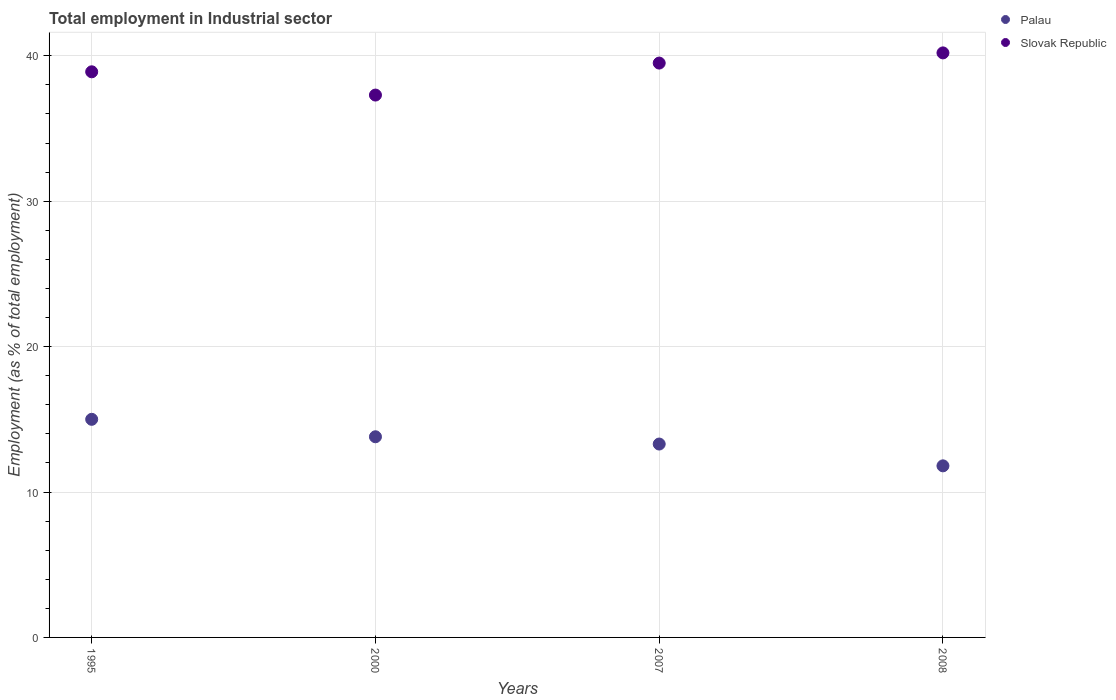How many different coloured dotlines are there?
Make the answer very short. 2. What is the employment in industrial sector in Slovak Republic in 2000?
Ensure brevity in your answer.  37.3. Across all years, what is the maximum employment in industrial sector in Palau?
Offer a terse response. 15. Across all years, what is the minimum employment in industrial sector in Palau?
Provide a short and direct response. 11.8. In which year was the employment in industrial sector in Palau maximum?
Offer a very short reply. 1995. What is the total employment in industrial sector in Slovak Republic in the graph?
Offer a terse response. 155.9. What is the difference between the employment in industrial sector in Slovak Republic in 1995 and that in 2000?
Your answer should be compact. 1.6. What is the difference between the employment in industrial sector in Palau in 2000 and the employment in industrial sector in Slovak Republic in 2008?
Your answer should be compact. -26.4. What is the average employment in industrial sector in Palau per year?
Make the answer very short. 13.48. In the year 2008, what is the difference between the employment in industrial sector in Palau and employment in industrial sector in Slovak Republic?
Keep it short and to the point. -28.4. What is the ratio of the employment in industrial sector in Slovak Republic in 2007 to that in 2008?
Provide a succinct answer. 0.98. Is the employment in industrial sector in Slovak Republic in 1995 less than that in 2008?
Your response must be concise. Yes. Is the difference between the employment in industrial sector in Palau in 2000 and 2008 greater than the difference between the employment in industrial sector in Slovak Republic in 2000 and 2008?
Provide a succinct answer. Yes. What is the difference between the highest and the second highest employment in industrial sector in Slovak Republic?
Provide a short and direct response. 0.7. What is the difference between the highest and the lowest employment in industrial sector in Slovak Republic?
Your answer should be compact. 2.9. In how many years, is the employment in industrial sector in Slovak Republic greater than the average employment in industrial sector in Slovak Republic taken over all years?
Offer a terse response. 2. How many dotlines are there?
Offer a terse response. 2. What is the difference between two consecutive major ticks on the Y-axis?
Offer a terse response. 10. Does the graph contain any zero values?
Your response must be concise. No. Does the graph contain grids?
Offer a very short reply. Yes. Where does the legend appear in the graph?
Keep it short and to the point. Top right. What is the title of the graph?
Make the answer very short. Total employment in Industrial sector. Does "Middle East & North Africa (developing only)" appear as one of the legend labels in the graph?
Your response must be concise. No. What is the label or title of the X-axis?
Give a very brief answer. Years. What is the label or title of the Y-axis?
Provide a short and direct response. Employment (as % of total employment). What is the Employment (as % of total employment) of Slovak Republic in 1995?
Your answer should be compact. 38.9. What is the Employment (as % of total employment) of Palau in 2000?
Ensure brevity in your answer.  13.8. What is the Employment (as % of total employment) of Slovak Republic in 2000?
Offer a terse response. 37.3. What is the Employment (as % of total employment) of Palau in 2007?
Provide a short and direct response. 13.3. What is the Employment (as % of total employment) in Slovak Republic in 2007?
Give a very brief answer. 39.5. What is the Employment (as % of total employment) of Palau in 2008?
Your response must be concise. 11.8. What is the Employment (as % of total employment) of Slovak Republic in 2008?
Offer a terse response. 40.2. Across all years, what is the maximum Employment (as % of total employment) of Slovak Republic?
Offer a very short reply. 40.2. Across all years, what is the minimum Employment (as % of total employment) in Palau?
Provide a short and direct response. 11.8. Across all years, what is the minimum Employment (as % of total employment) in Slovak Republic?
Your response must be concise. 37.3. What is the total Employment (as % of total employment) of Palau in the graph?
Your answer should be compact. 53.9. What is the total Employment (as % of total employment) of Slovak Republic in the graph?
Your answer should be compact. 155.9. What is the difference between the Employment (as % of total employment) in Slovak Republic in 1995 and that in 2007?
Keep it short and to the point. -0.6. What is the difference between the Employment (as % of total employment) of Slovak Republic in 1995 and that in 2008?
Keep it short and to the point. -1.3. What is the difference between the Employment (as % of total employment) in Palau in 2000 and that in 2007?
Provide a short and direct response. 0.5. What is the difference between the Employment (as % of total employment) of Slovak Republic in 2000 and that in 2007?
Provide a short and direct response. -2.2. What is the difference between the Employment (as % of total employment) of Palau in 2000 and that in 2008?
Give a very brief answer. 2. What is the difference between the Employment (as % of total employment) of Palau in 2007 and that in 2008?
Offer a very short reply. 1.5. What is the difference between the Employment (as % of total employment) in Palau in 1995 and the Employment (as % of total employment) in Slovak Republic in 2000?
Make the answer very short. -22.3. What is the difference between the Employment (as % of total employment) of Palau in 1995 and the Employment (as % of total employment) of Slovak Republic in 2007?
Keep it short and to the point. -24.5. What is the difference between the Employment (as % of total employment) of Palau in 1995 and the Employment (as % of total employment) of Slovak Republic in 2008?
Make the answer very short. -25.2. What is the difference between the Employment (as % of total employment) in Palau in 2000 and the Employment (as % of total employment) in Slovak Republic in 2007?
Your answer should be compact. -25.7. What is the difference between the Employment (as % of total employment) in Palau in 2000 and the Employment (as % of total employment) in Slovak Republic in 2008?
Give a very brief answer. -26.4. What is the difference between the Employment (as % of total employment) in Palau in 2007 and the Employment (as % of total employment) in Slovak Republic in 2008?
Keep it short and to the point. -26.9. What is the average Employment (as % of total employment) in Palau per year?
Give a very brief answer. 13.47. What is the average Employment (as % of total employment) of Slovak Republic per year?
Your answer should be very brief. 38.98. In the year 1995, what is the difference between the Employment (as % of total employment) of Palau and Employment (as % of total employment) of Slovak Republic?
Make the answer very short. -23.9. In the year 2000, what is the difference between the Employment (as % of total employment) in Palau and Employment (as % of total employment) in Slovak Republic?
Give a very brief answer. -23.5. In the year 2007, what is the difference between the Employment (as % of total employment) in Palau and Employment (as % of total employment) in Slovak Republic?
Ensure brevity in your answer.  -26.2. In the year 2008, what is the difference between the Employment (as % of total employment) in Palau and Employment (as % of total employment) in Slovak Republic?
Your response must be concise. -28.4. What is the ratio of the Employment (as % of total employment) of Palau in 1995 to that in 2000?
Offer a terse response. 1.09. What is the ratio of the Employment (as % of total employment) of Slovak Republic in 1995 to that in 2000?
Your answer should be very brief. 1.04. What is the ratio of the Employment (as % of total employment) in Palau in 1995 to that in 2007?
Offer a very short reply. 1.13. What is the ratio of the Employment (as % of total employment) in Palau in 1995 to that in 2008?
Provide a succinct answer. 1.27. What is the ratio of the Employment (as % of total employment) in Slovak Republic in 1995 to that in 2008?
Make the answer very short. 0.97. What is the ratio of the Employment (as % of total employment) of Palau in 2000 to that in 2007?
Your answer should be very brief. 1.04. What is the ratio of the Employment (as % of total employment) in Slovak Republic in 2000 to that in 2007?
Make the answer very short. 0.94. What is the ratio of the Employment (as % of total employment) in Palau in 2000 to that in 2008?
Provide a succinct answer. 1.17. What is the ratio of the Employment (as % of total employment) in Slovak Republic in 2000 to that in 2008?
Provide a short and direct response. 0.93. What is the ratio of the Employment (as % of total employment) in Palau in 2007 to that in 2008?
Provide a short and direct response. 1.13. What is the ratio of the Employment (as % of total employment) of Slovak Republic in 2007 to that in 2008?
Your response must be concise. 0.98. What is the difference between the highest and the second highest Employment (as % of total employment) in Palau?
Keep it short and to the point. 1.2. What is the difference between the highest and the lowest Employment (as % of total employment) in Palau?
Offer a terse response. 3.2. What is the difference between the highest and the lowest Employment (as % of total employment) in Slovak Republic?
Ensure brevity in your answer.  2.9. 